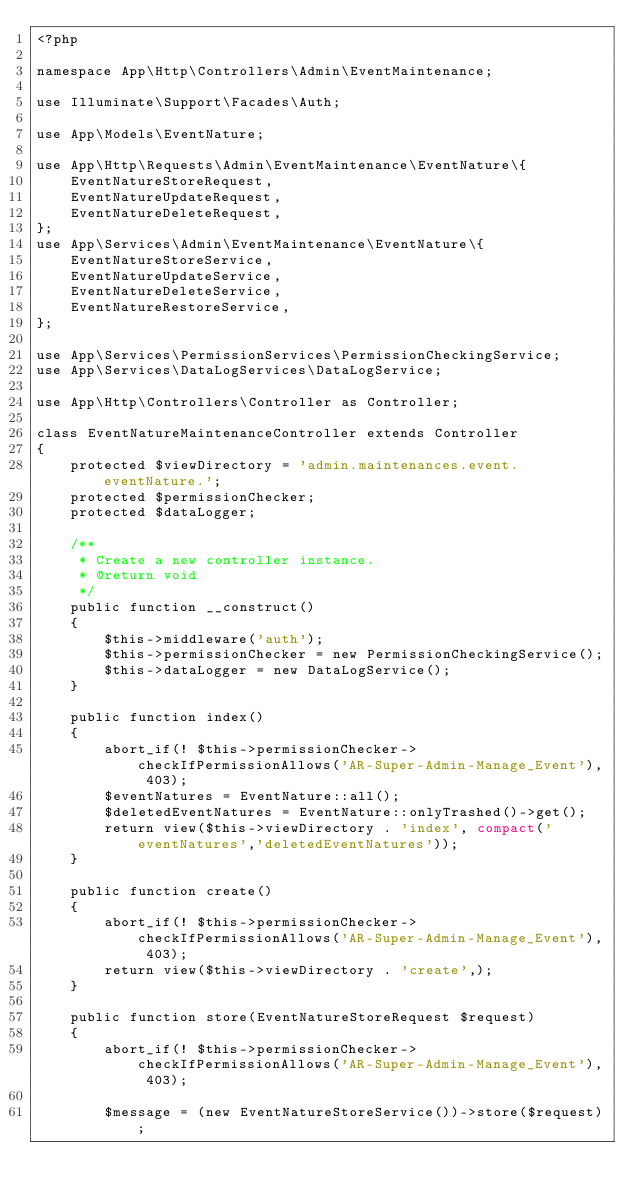Convert code to text. <code><loc_0><loc_0><loc_500><loc_500><_PHP_><?php

namespace App\Http\Controllers\Admin\EventMaintenance;

use Illuminate\Support\Facades\Auth;

use App\Models\EventNature;

use App\Http\Requests\Admin\EventMaintenance\EventNature\{
    EventNatureStoreRequest,
    EventNatureUpdateRequest,
    EventNatureDeleteRequest,
};
use App\Services\Admin\EventMaintenance\EventNature\{
    EventNatureStoreService,
    EventNatureUpdateService,
    EventNatureDeleteService,
    EventNatureRestoreService,
};

use App\Services\PermissionServices\PermissionCheckingService;
use App\Services\DataLogServices\DataLogService;

use App\Http\Controllers\Controller as Controller;

class EventNatureMaintenanceController extends Controller
{
    protected $viewDirectory = 'admin.maintenances.event.eventNature.';
    protected $permissionChecker;
    protected $dataLogger;

    /**
     * Create a new controller instance.
     * @return void
     */
    public function __construct()
    {
        $this->middleware('auth');
        $this->permissionChecker = new PermissionCheckingService();
        $this->dataLogger = new DataLogService();
    }

    public function index()
    {
        abort_if(! $this->permissionChecker->checkIfPermissionAllows('AR-Super-Admin-Manage_Event'), 403);
        $eventNatures = EventNature::all();
        $deletedEventNatures = EventNature::onlyTrashed()->get();
        return view($this->viewDirectory . 'index', compact('eventNatures','deletedEventNatures'));
    }
    
    public function create()
    {
        abort_if(! $this->permissionChecker->checkIfPermissionAllows('AR-Super-Admin-Manage_Event'), 403);
        return view($this->viewDirectory . 'create',);
    }

    public function store(EventNatureStoreRequest $request)
    {
        abort_if(! $this->permissionChecker->checkIfPermissionAllows('AR-Super-Admin-Manage_Event'), 403);

        $message = (new EventNatureStoreService())->store($request);
</code> 